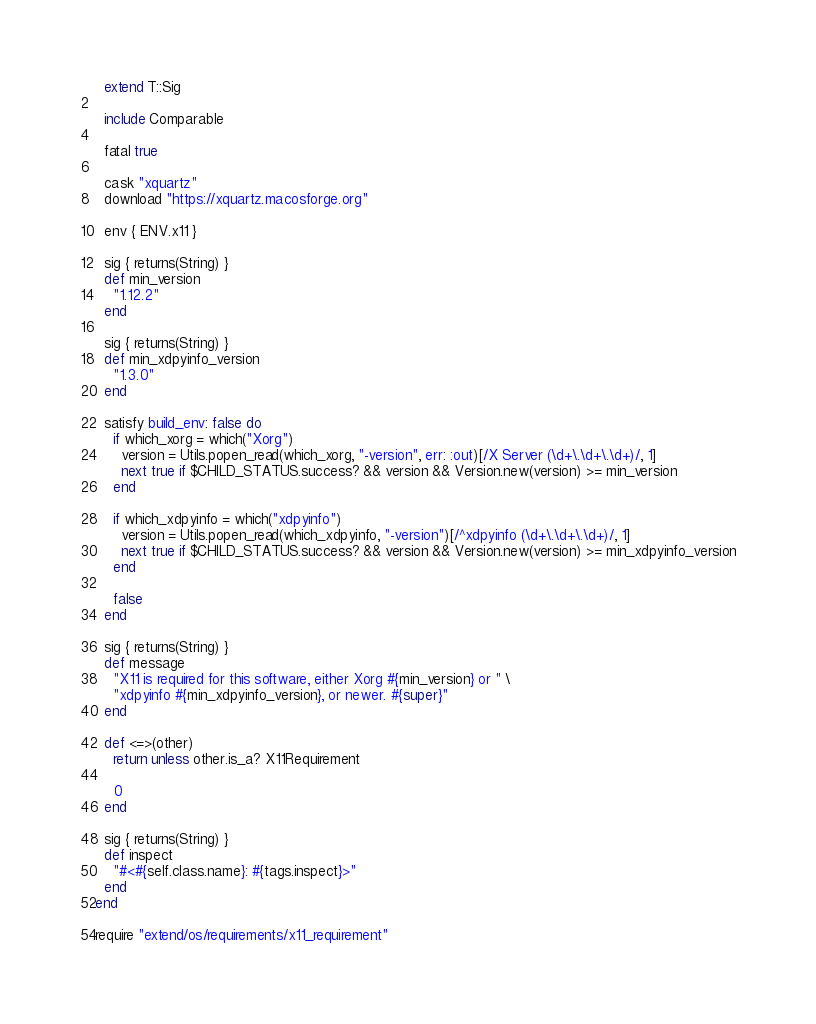Convert code to text. <code><loc_0><loc_0><loc_500><loc_500><_Ruby_>  extend T::Sig

  include Comparable

  fatal true

  cask "xquartz"
  download "https://xquartz.macosforge.org"

  env { ENV.x11 }

  sig { returns(String) }
  def min_version
    "1.12.2"
  end

  sig { returns(String) }
  def min_xdpyinfo_version
    "1.3.0"
  end

  satisfy build_env: false do
    if which_xorg = which("Xorg")
      version = Utils.popen_read(which_xorg, "-version", err: :out)[/X Server (\d+\.\d+\.\d+)/, 1]
      next true if $CHILD_STATUS.success? && version && Version.new(version) >= min_version
    end

    if which_xdpyinfo = which("xdpyinfo")
      version = Utils.popen_read(which_xdpyinfo, "-version")[/^xdpyinfo (\d+\.\d+\.\d+)/, 1]
      next true if $CHILD_STATUS.success? && version && Version.new(version) >= min_xdpyinfo_version
    end

    false
  end

  sig { returns(String) }
  def message
    "X11 is required for this software, either Xorg #{min_version} or " \
    "xdpyinfo #{min_xdpyinfo_version}, or newer. #{super}"
  end

  def <=>(other)
    return unless other.is_a? X11Requirement

    0
  end

  sig { returns(String) }
  def inspect
    "#<#{self.class.name}: #{tags.inspect}>"
  end
end

require "extend/os/requirements/x11_requirement"
</code> 